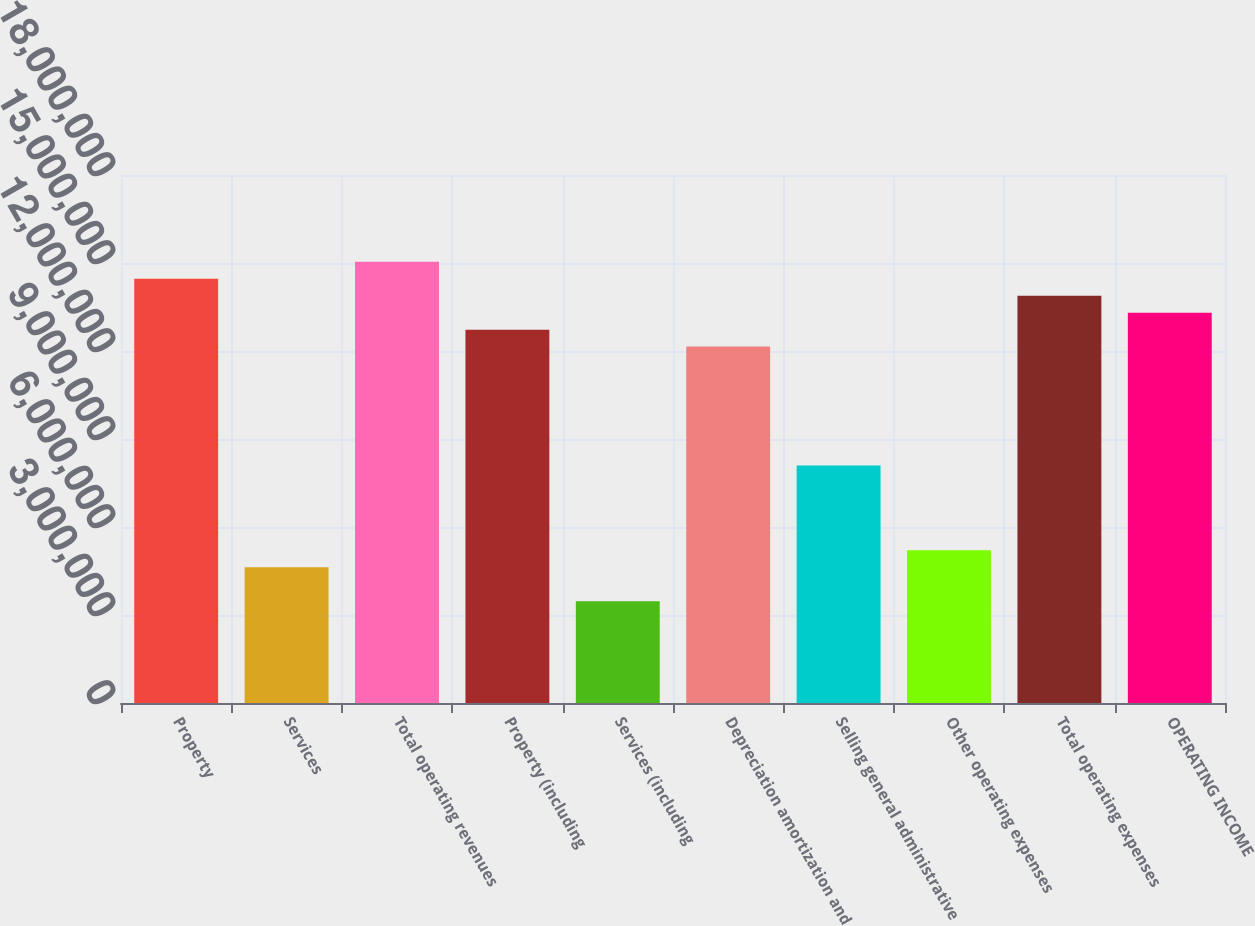Convert chart. <chart><loc_0><loc_0><loc_500><loc_500><bar_chart><fcel>Property<fcel>Services<fcel>Total operating revenues<fcel>Property (including<fcel>Services (including<fcel>Depreciation amortization and<fcel>Selling general administrative<fcel>Other operating expenses<fcel>Total operating expenses<fcel>OPERATING INCOME<nl><fcel>1.44642e+07<fcel>4.62853e+06<fcel>1.50427e+07<fcel>1.27285e+07<fcel>3.4714e+06<fcel>1.21499e+07<fcel>8.09993e+06<fcel>5.2071e+06<fcel>1.38856e+07<fcel>1.3307e+07<nl></chart> 